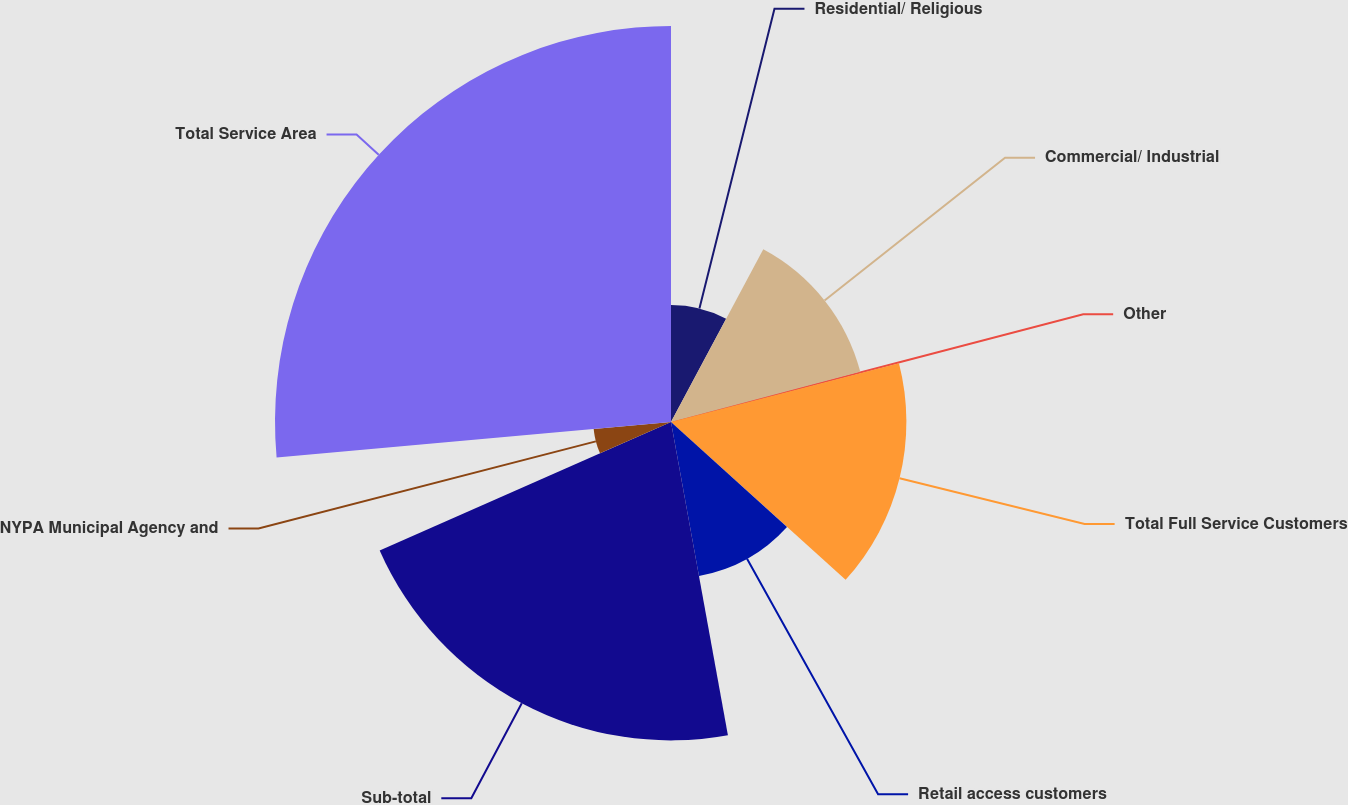Convert chart to OTSL. <chart><loc_0><loc_0><loc_500><loc_500><pie_chart><fcel>Residential/ Religious<fcel>Commercial/ Industrial<fcel>Other<fcel>Total Full Service Customers<fcel>Retail access customers<fcel>Sub-total<fcel>NYPA Municipal Agency and<fcel>Total Service Area<nl><fcel>7.81%<fcel>13.07%<fcel>0.11%<fcel>15.71%<fcel>10.44%<fcel>21.25%<fcel>5.18%<fcel>26.43%<nl></chart> 